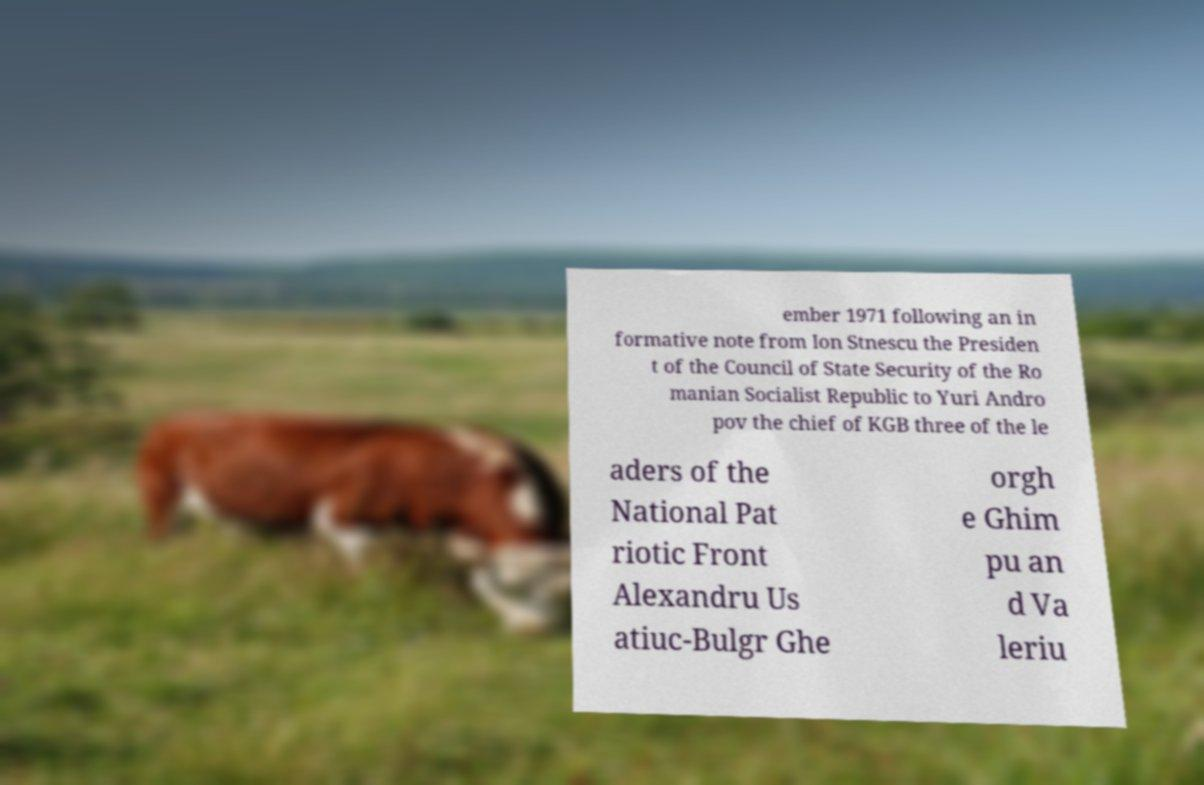I need the written content from this picture converted into text. Can you do that? ember 1971 following an in formative note from Ion Stnescu the Presiden t of the Council of State Security of the Ro manian Socialist Republic to Yuri Andro pov the chief of KGB three of the le aders of the National Pat riotic Front Alexandru Us atiuc-Bulgr Ghe orgh e Ghim pu an d Va leriu 